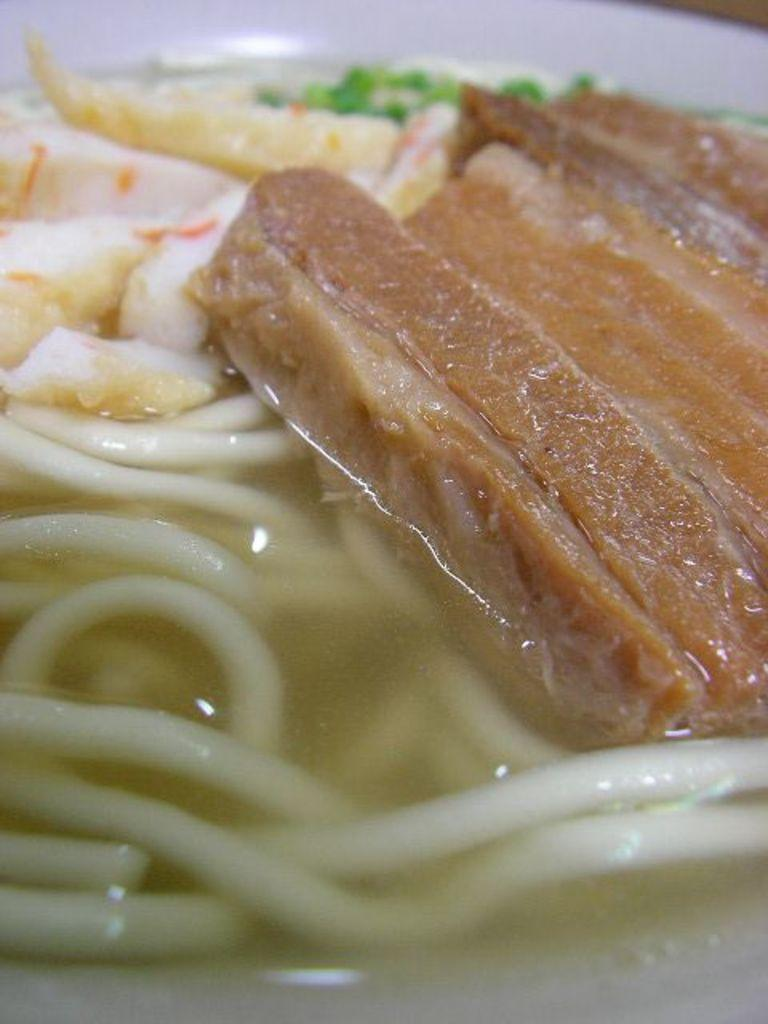What type of food is the main subject of the image? There are noodles in the image. Are there any other food items present in the image? Yes, there are other food items in the image. What is the color of the surface on which the food items are placed? The surface on which the food items are placed is white in color. Can you see any mountains in the image? There are no mountains present in the image. What type of silk is used to make the pocket in the image? There is no silk or pocket present in the image. 